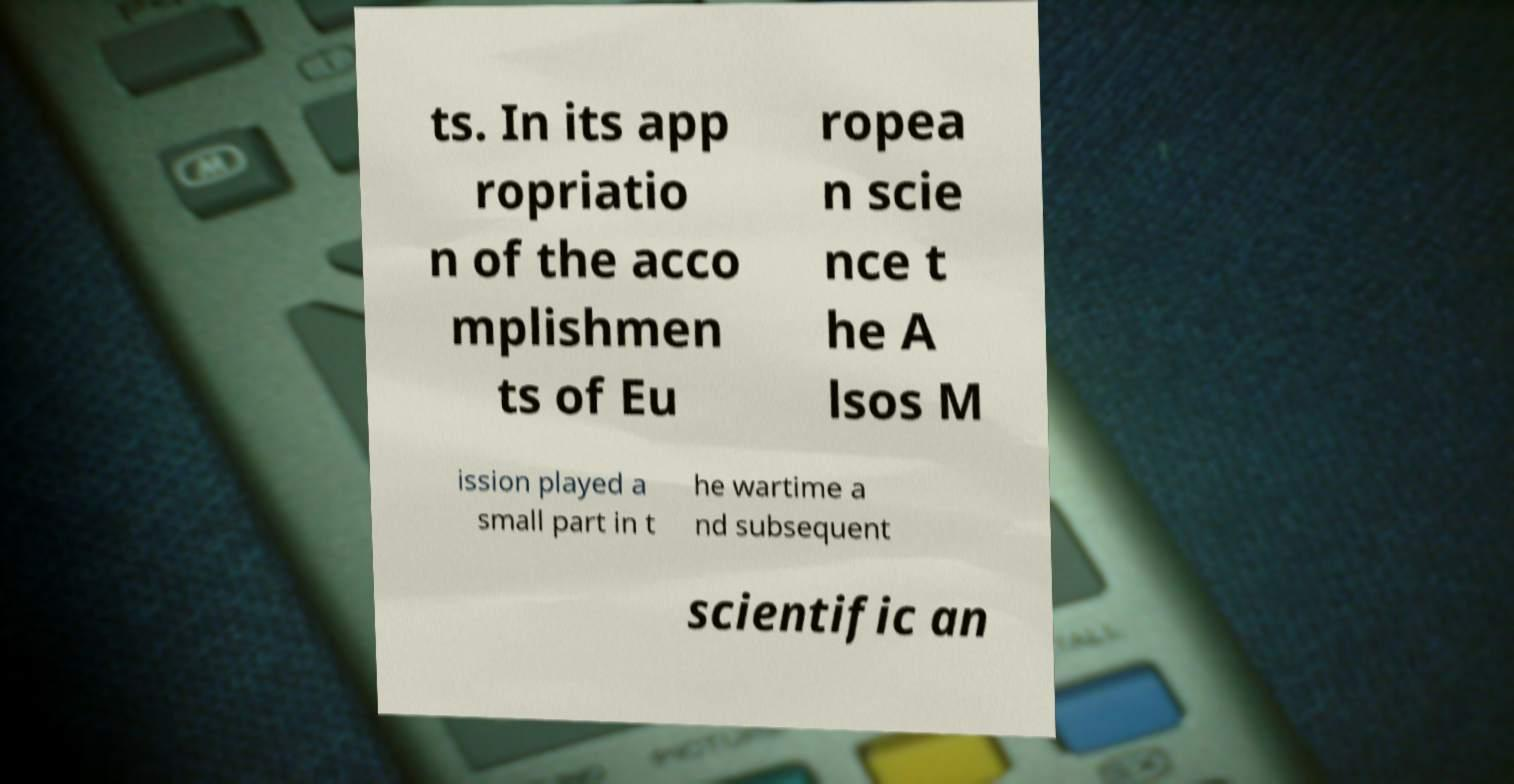Can you read and provide the text displayed in the image?This photo seems to have some interesting text. Can you extract and type it out for me? ts. In its app ropriatio n of the acco mplishmen ts of Eu ropea n scie nce t he A lsos M ission played a small part in t he wartime a nd subsequent scientific an 